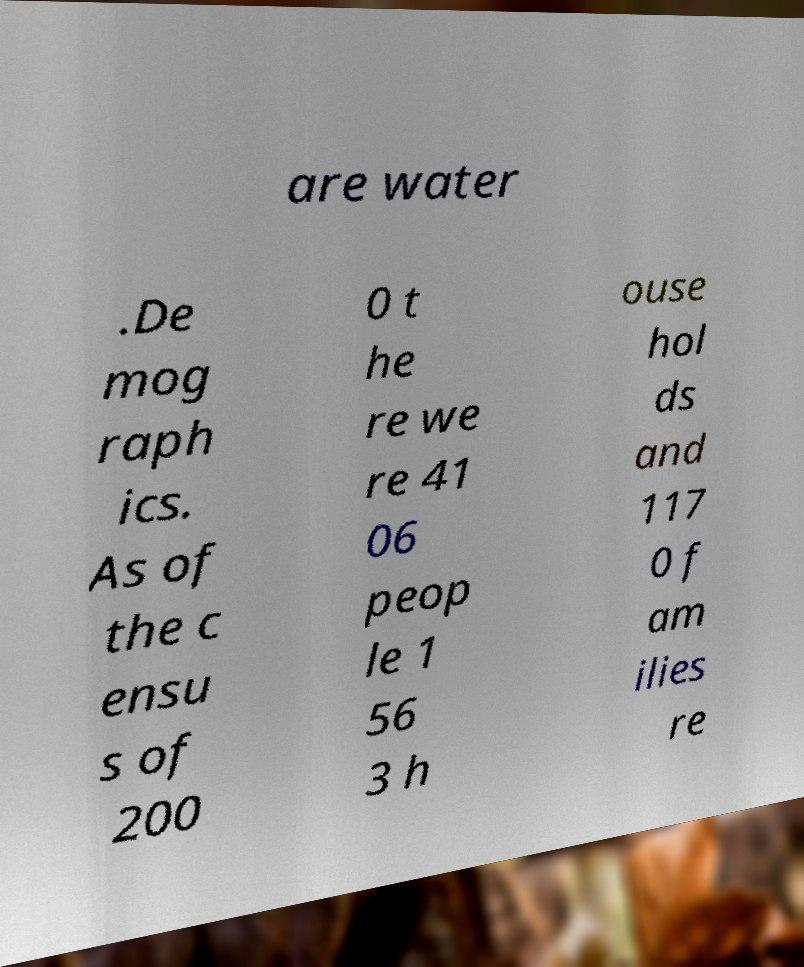There's text embedded in this image that I need extracted. Can you transcribe it verbatim? are water .De mog raph ics. As of the c ensu s of 200 0 t he re we re 41 06 peop le 1 56 3 h ouse hol ds and 117 0 f am ilies re 